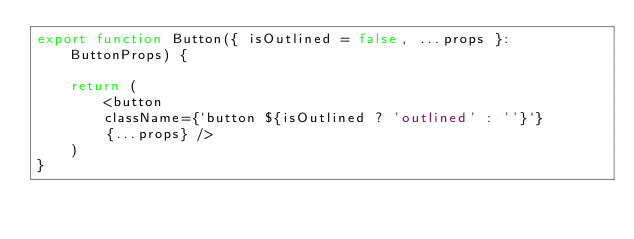Convert code to text. <code><loc_0><loc_0><loc_500><loc_500><_TypeScript_>export function Button({ isOutlined = false, ...props }: ButtonProps) {

    return (
        <button 
        className={`button ${isOutlined ? 'outlined' : ''}`}
        {...props} />
    )
}
</code> 